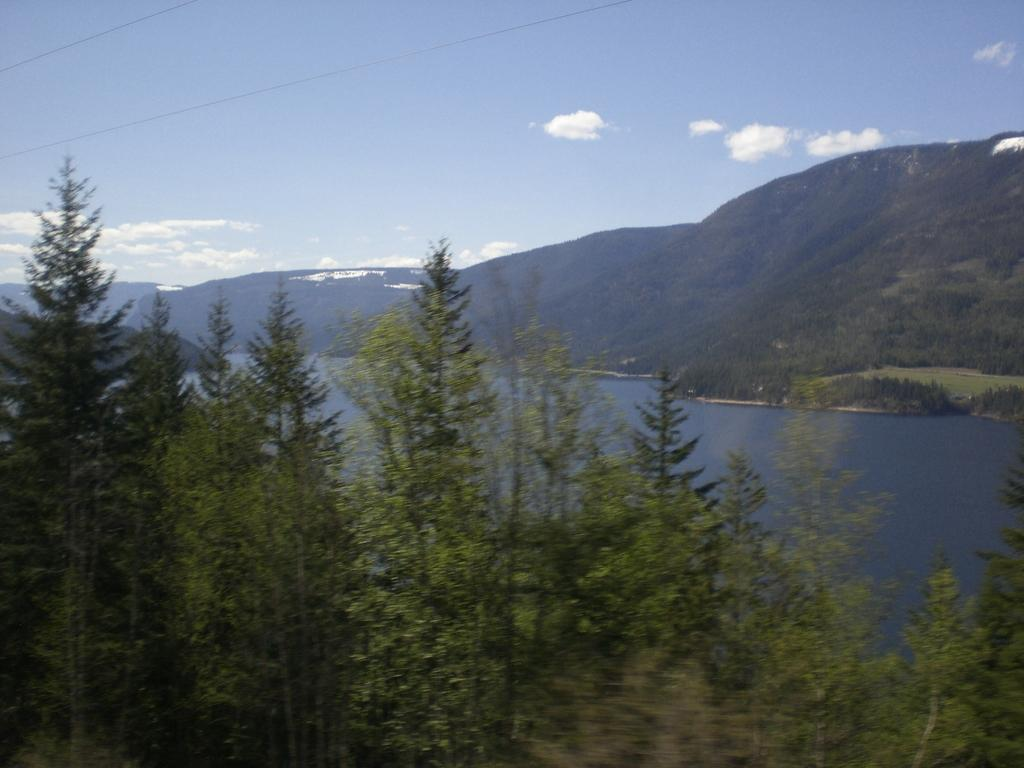What type of vegetation is at the bottom of the image? There are trees at the bottom of the image. What is located in the middle of the image? There is water in the middle of the image. What geographical feature can be seen on the right side of the image? There are hills on the right side of the image. What is visible at the top of the image? The sky is visible at the top of the image. What type of silk is being used to create the clouds in the image? There is no silk present in the image, and the clouds are not made of any material. What belief system is depicted in the image? There is no specific belief system depicted in the image; it features natural elements such as trees, water, hills, and sky. 